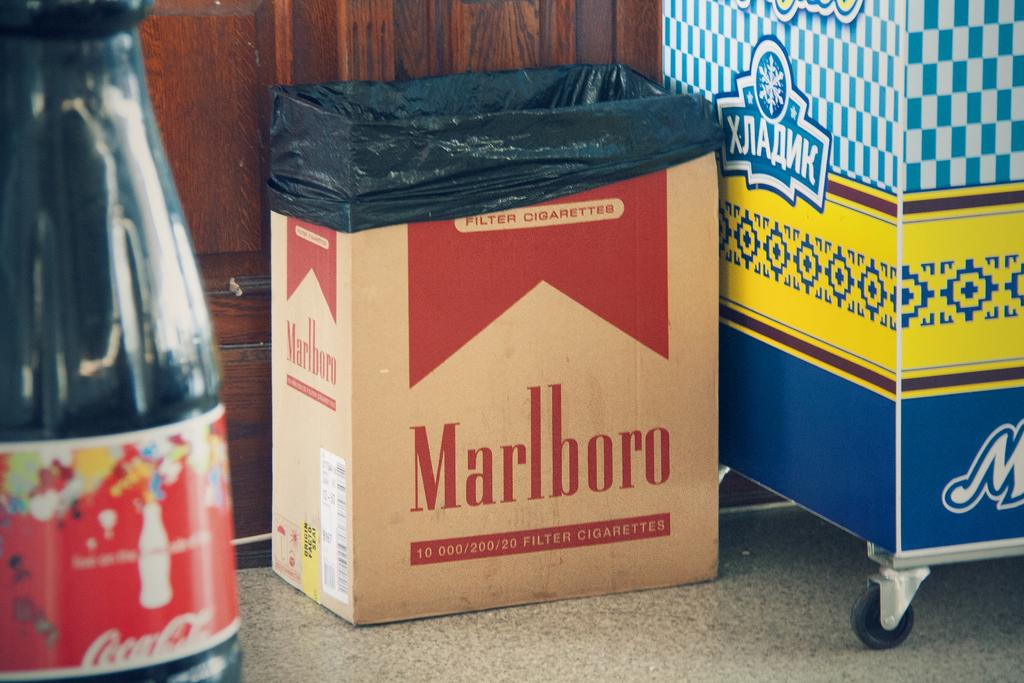<image>
Give a short and clear explanation of the subsequent image. A cardboard trash can bears the brand name Marlboro. 